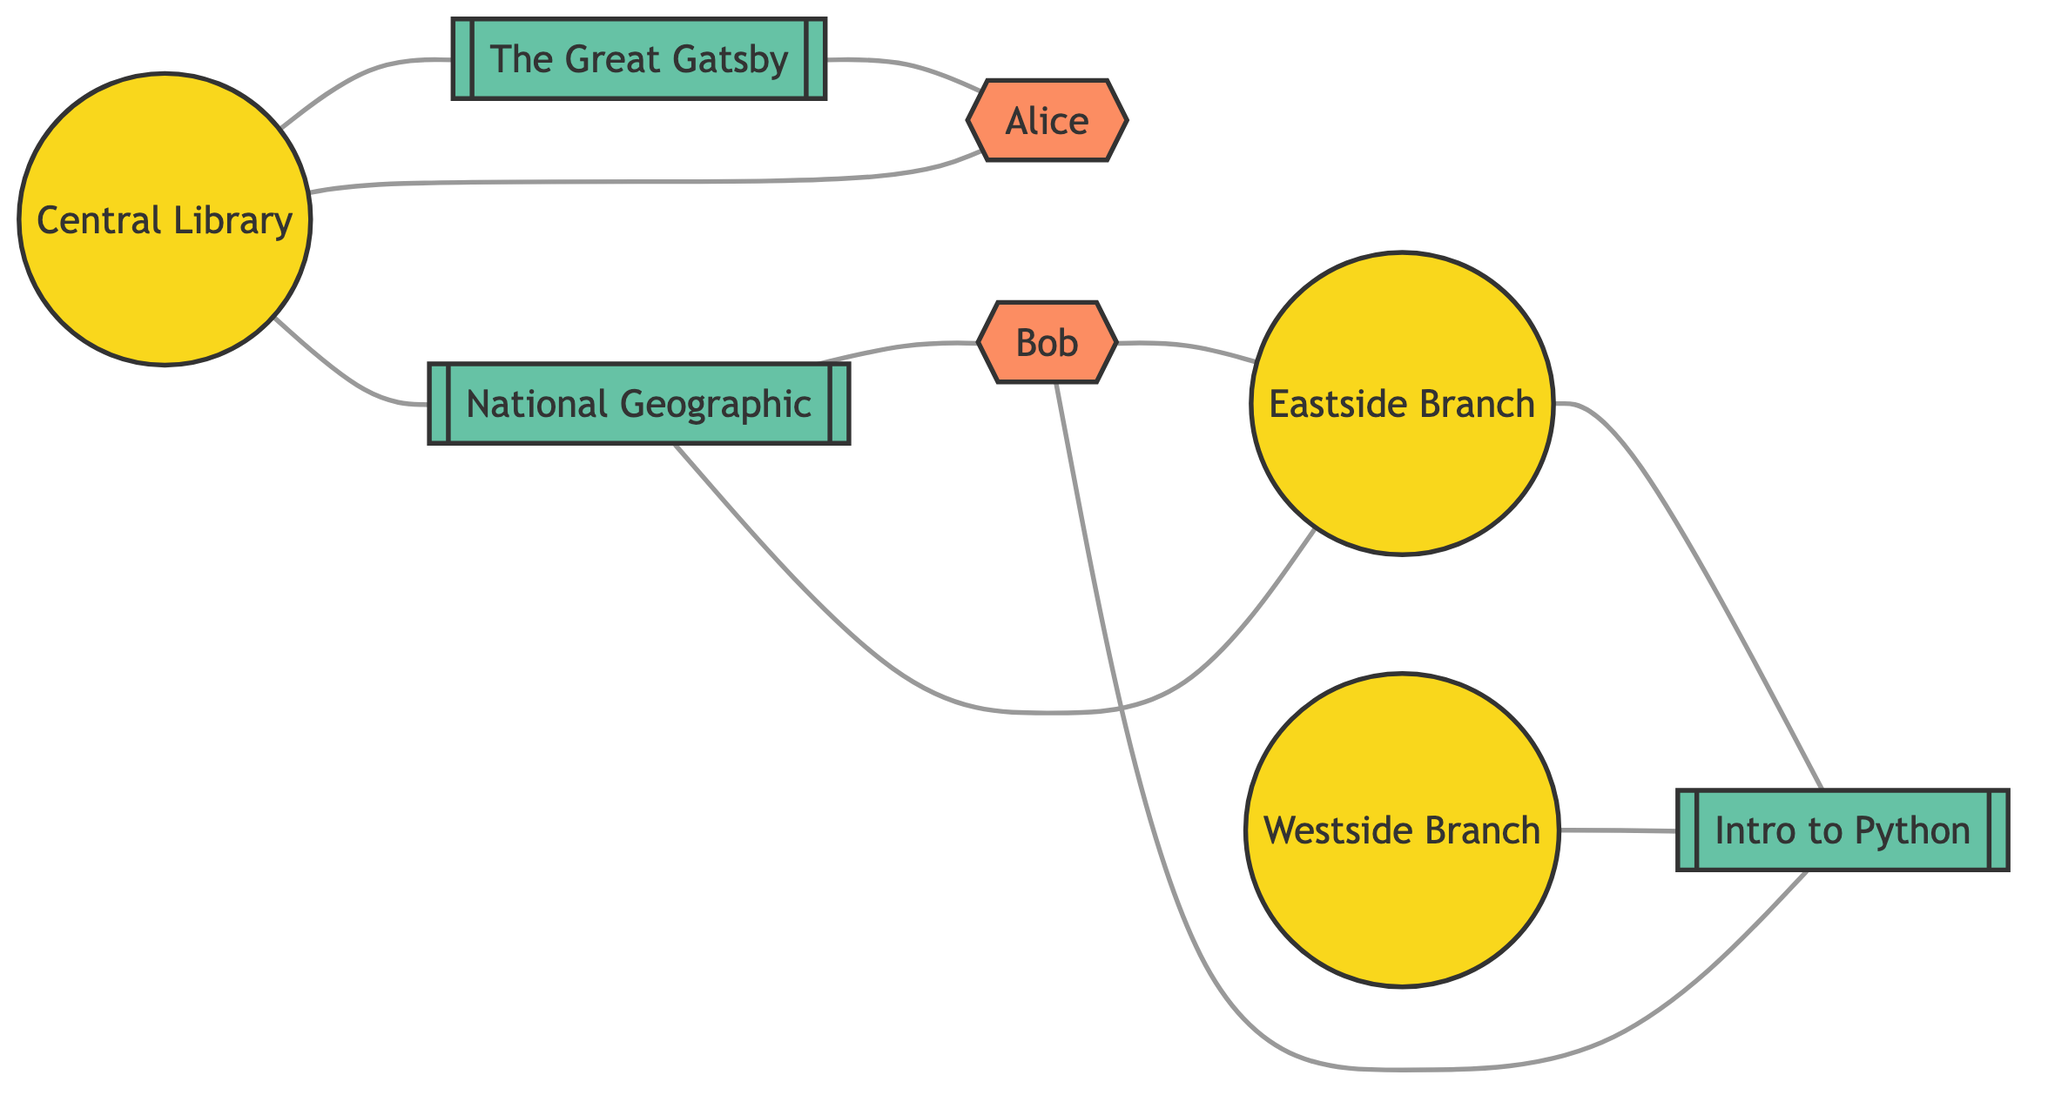What are the names of the library branches? The diagram has three nodes labeled as "Library Branch." Listing their names, we get Central Library, Eastside Branch, and Westside Branch.
Answer: Central Library, Eastside Branch, Westside Branch How many users are represented in the diagram? There are two nodes labeled as "User," which are Alice and Bob. Counting these nodes gives a total of two users.
Answer: 2 Which resource item is borrowed by Bob? Tracing the edges, we see that the resource item linked to the user Bob is National Geographic Magazine, as indicated by the borrowed_by relationship.
Answer: National Geographic Magazine Which library branch has the resource item "Introduction to Python Programming"? By checking the edges connected to the resource item Introduction to Python Programming, we see it is linked to the Westside Branch, as indicated by the has relationship.
Answer: Westside Branch What relationship connects Alice to the Central Library? The relationship is labeled as "registered_at," indicating that Alice is registered at the Central Library. This is displayed in the diagram through an edge between Alice and the Central Library.
Answer: registered_at Which user is registered at the Eastside Branch? To find this, we look for connections from the user nodes to the Eastside Branch using the registered_at relationship. Here, Bob is connected to Eastside Branch through this relationship.
Answer: Bob How many total edges are in the diagram? Counting all the edges in the diagram, we find there are ten edges connecting various nodes, representing relationships among library branches, users, and resource items.
Answer: 10 Which resource item does the Central Library have that the Eastside Branch does not? By examining the edges connecting both branches to resource items, we find the Central Library has The Great Gatsby, which is not connected to the Eastside Branch.
Answer: The Great Gatsby What is the total number of resource items depicted in the diagram? There are four nodes labeled as "Resource Item" including The Great Gatsby, National Geographic Magazine, Introduction to Python Programming, and the respective connections representing these items, totaling four resource items in the diagram.
Answer: 4 